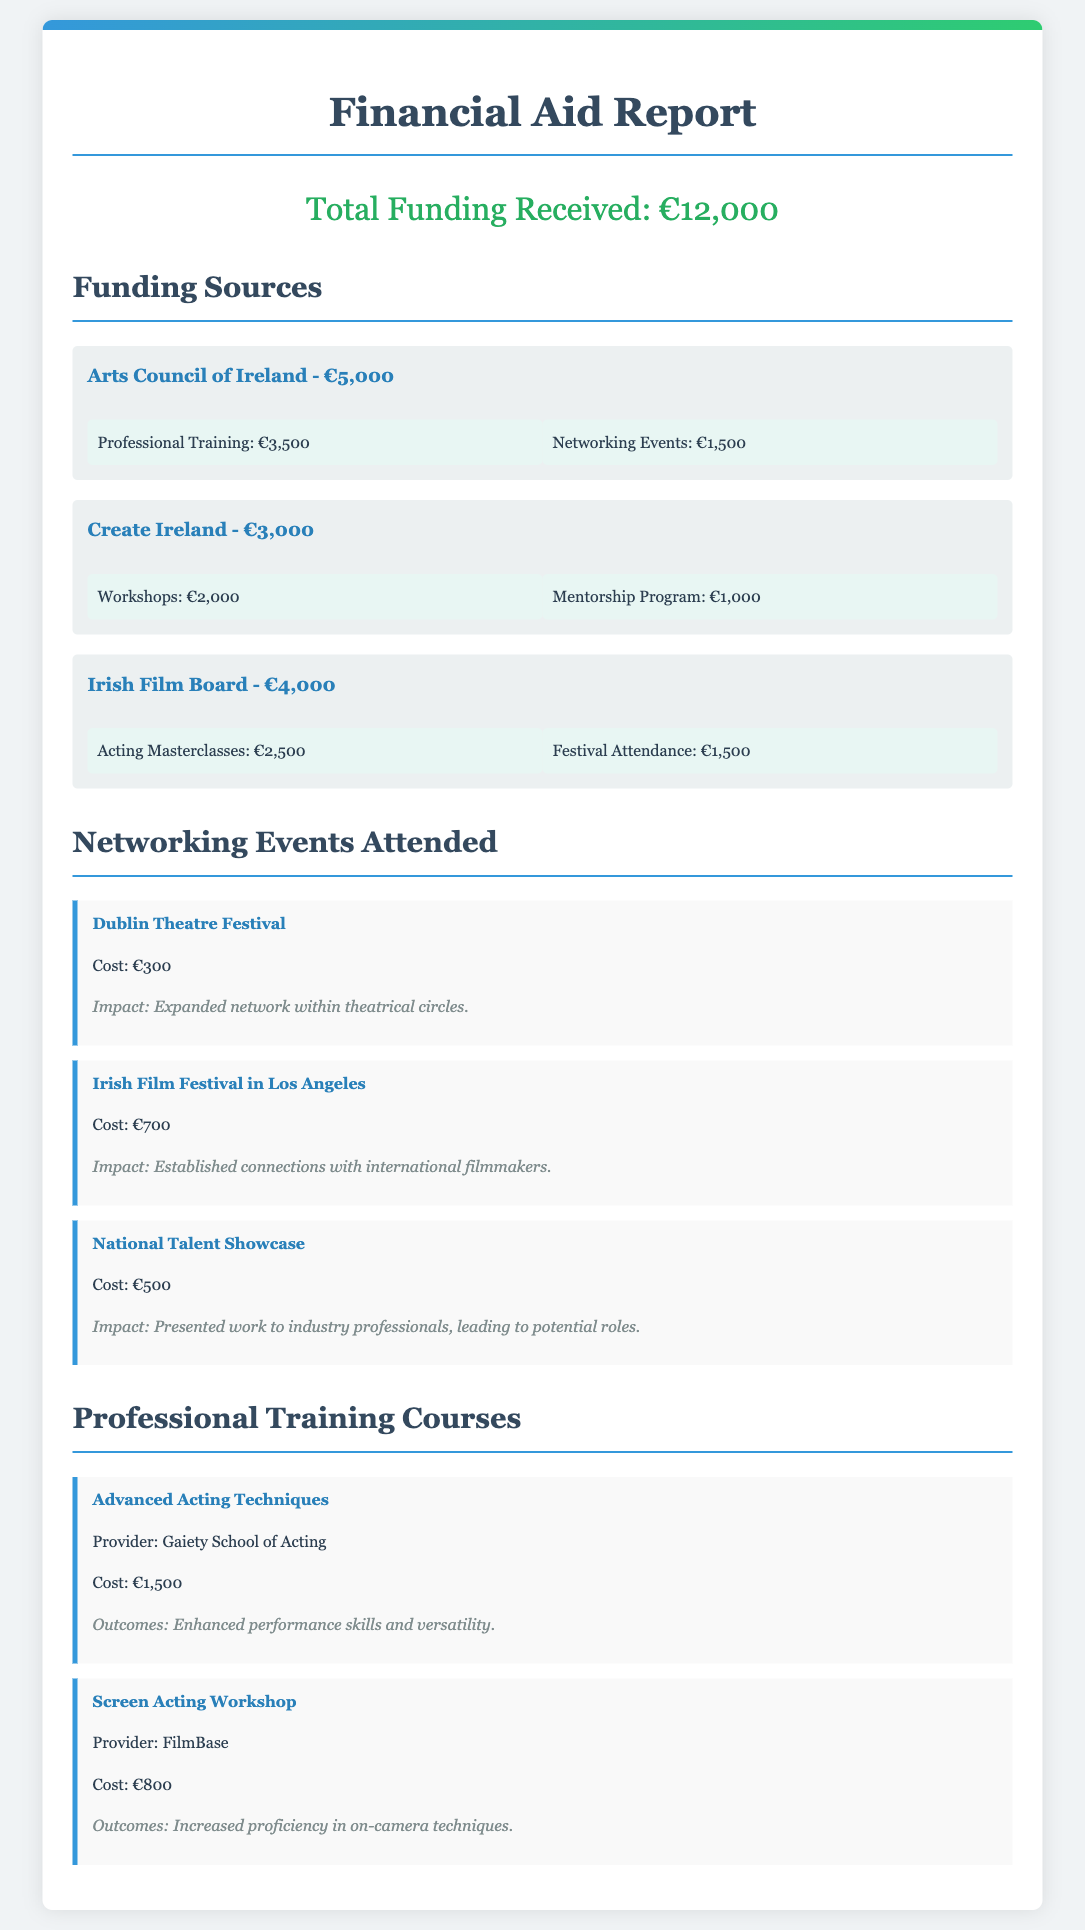What is the total funding received? The total funding is explicitly mentioned at the beginning of the document.
Answer: €12,000 How much did the Arts Council of Ireland provide? The funding sources section lists the amount provided by the Arts Council of Ireland.
Answer: €5,000 What percentage of the total funding is allocated for professional training? Professional training allocation is €3,500 out of a total of €12,000, requiring a calculation.
Answer: 29.17% Which networking event cost the most? The costs of the networking events are listed, and the highest amount indicates the most expensive event.
Answer: €700 What is the outcome of the "Advanced Acting Techniques" course? The outcome is specifically mentioned under the course details.
Answer: Enhanced performance skills and versatility How much funding did Create Ireland provide for workshops? The allocation details for Create Ireland indicate the workshop funding amount.
Answer: €2,000 What is the total amount allocated for networking events? Summing the networking event allocations will provide the total amount allocated.
Answer: €3,500 Which provider offered the course "Screen Acting Workshop"? This information is found under the course details for the "Screen Acting Workshop."
Answer: FilmBase How many networking events were attended? The document lists three networking events attended, indicated in the relevant section.
Answer: 3 